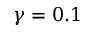<formula> <loc_0><loc_0><loc_500><loc_500>\gamma = 0 . 1</formula> 